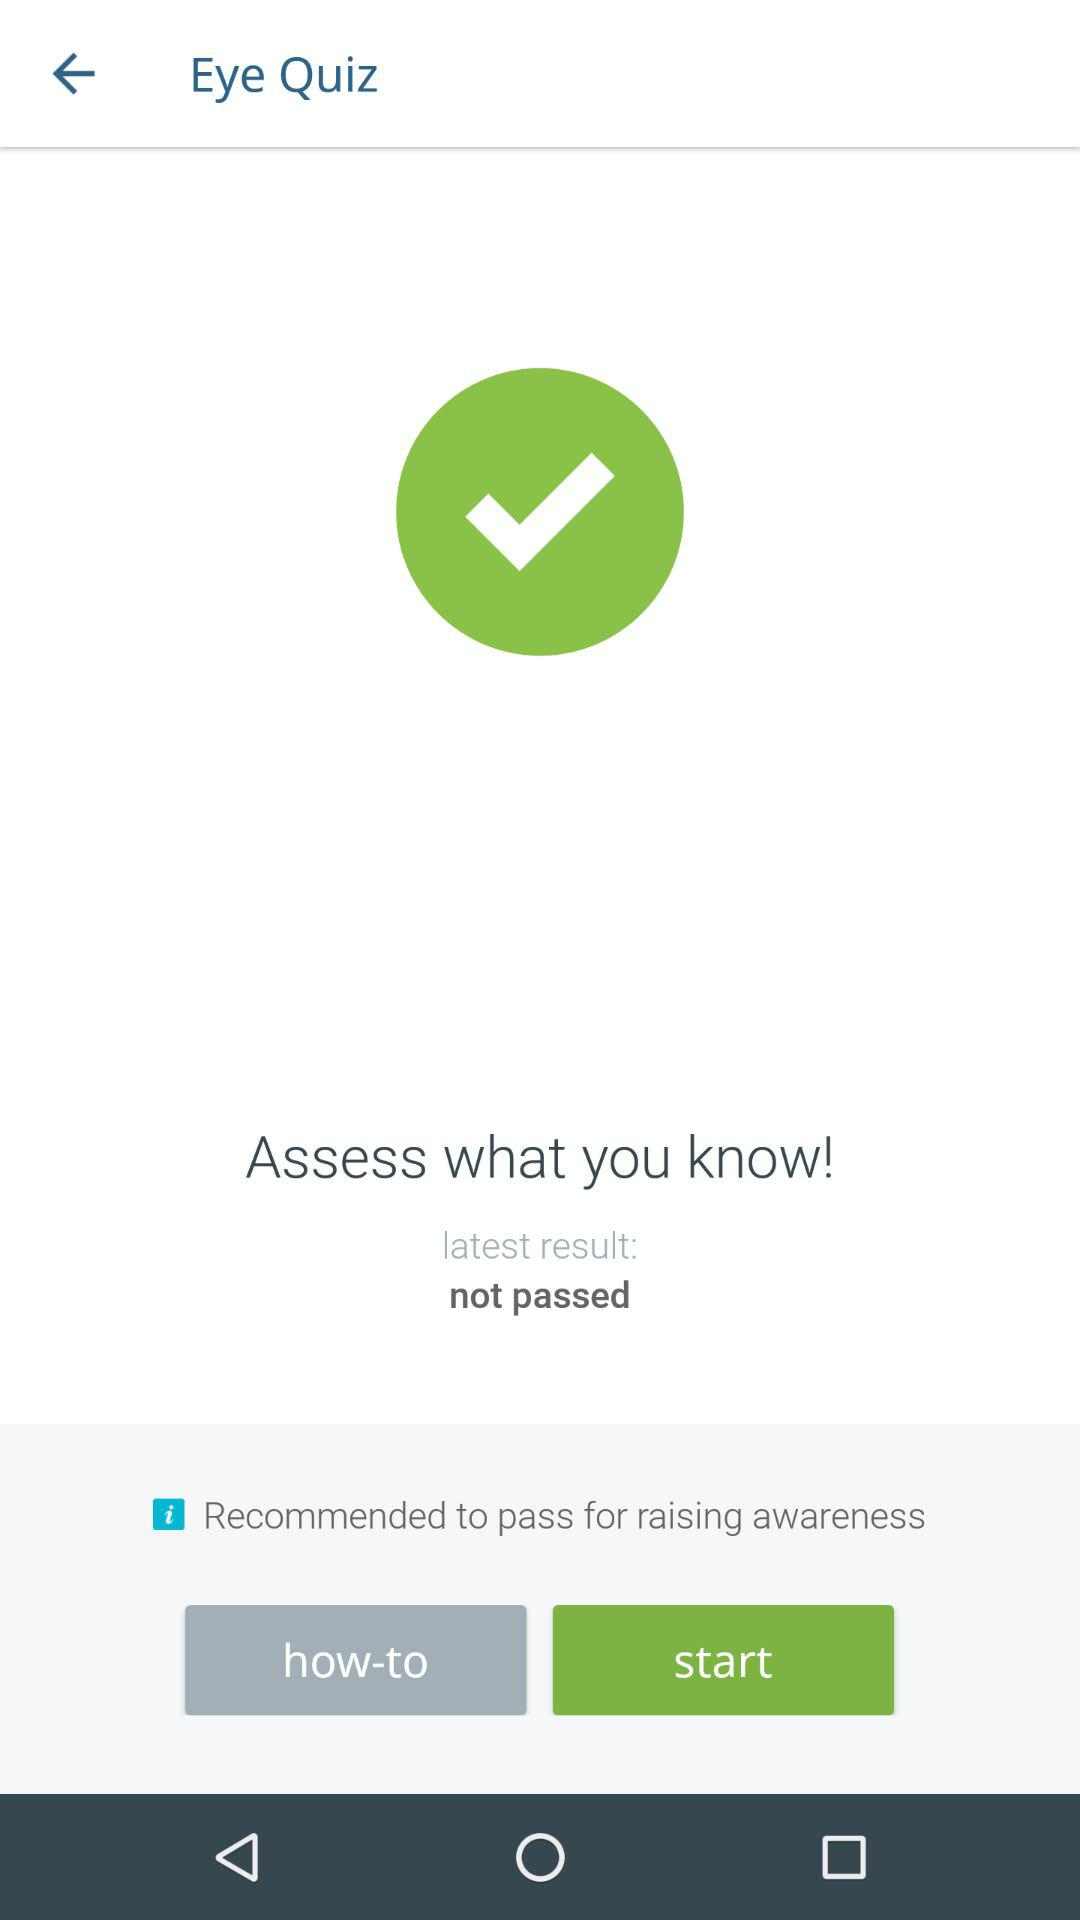What is the latest result of the Eye Quiz? The latest result is not passed. 